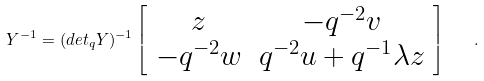<formula> <loc_0><loc_0><loc_500><loc_500>Y ^ { - 1 } = ( d e t _ { q } Y ) ^ { - 1 } \left [ \begin{array} { c c } z & - q ^ { - 2 } v \\ - q ^ { - 2 } w & q ^ { - 2 } u + q ^ { - 1 } \lambda z \end{array} \right ] \quad .</formula> 